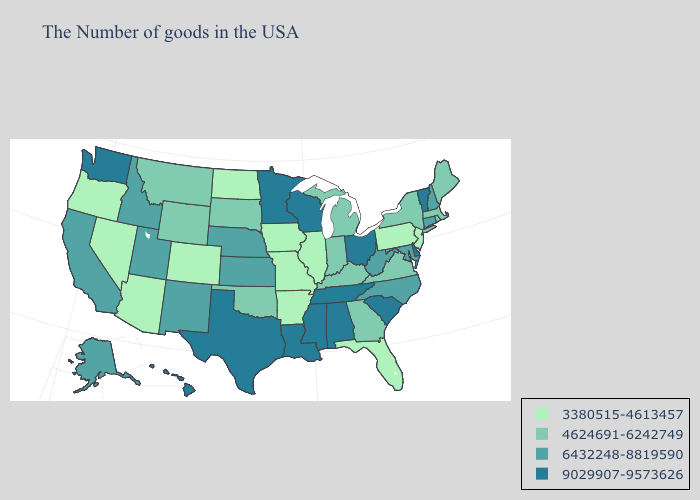Does Kentucky have a lower value than West Virginia?
Give a very brief answer. Yes. Name the states that have a value in the range 6432248-8819590?
Answer briefly. New Hampshire, Connecticut, Maryland, North Carolina, West Virginia, Kansas, Nebraska, New Mexico, Utah, Idaho, California, Alaska. Does Kentucky have the highest value in the South?
Concise answer only. No. What is the value of Ohio?
Concise answer only. 9029907-9573626. Name the states that have a value in the range 9029907-9573626?
Give a very brief answer. Vermont, Delaware, South Carolina, Ohio, Alabama, Tennessee, Wisconsin, Mississippi, Louisiana, Minnesota, Texas, Washington, Hawaii. Among the states that border Arizona , which have the highest value?
Keep it brief. New Mexico, Utah, California. Does New Hampshire have the lowest value in the USA?
Write a very short answer. No. Among the states that border Arizona , which have the lowest value?
Be succinct. Colorado, Nevada. What is the highest value in the West ?
Short answer required. 9029907-9573626. What is the lowest value in states that border Delaware?
Be succinct. 3380515-4613457. How many symbols are there in the legend?
Give a very brief answer. 4. Does Tennessee have the highest value in the South?
Short answer required. Yes. Name the states that have a value in the range 9029907-9573626?
Short answer required. Vermont, Delaware, South Carolina, Ohio, Alabama, Tennessee, Wisconsin, Mississippi, Louisiana, Minnesota, Texas, Washington, Hawaii. Among the states that border Kentucky , which have the highest value?
Keep it brief. Ohio, Tennessee. Name the states that have a value in the range 4624691-6242749?
Answer briefly. Maine, Massachusetts, Rhode Island, New York, Virginia, Georgia, Michigan, Kentucky, Indiana, Oklahoma, South Dakota, Wyoming, Montana. 